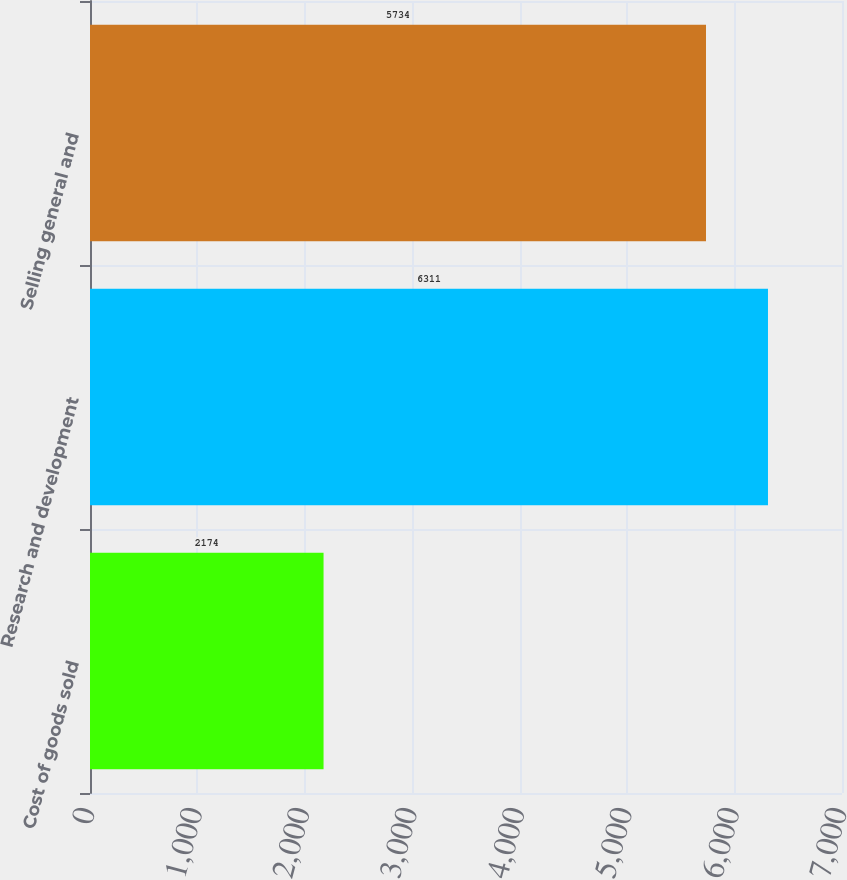Convert chart to OTSL. <chart><loc_0><loc_0><loc_500><loc_500><bar_chart><fcel>Cost of goods sold<fcel>Research and development<fcel>Selling general and<nl><fcel>2174<fcel>6311<fcel>5734<nl></chart> 